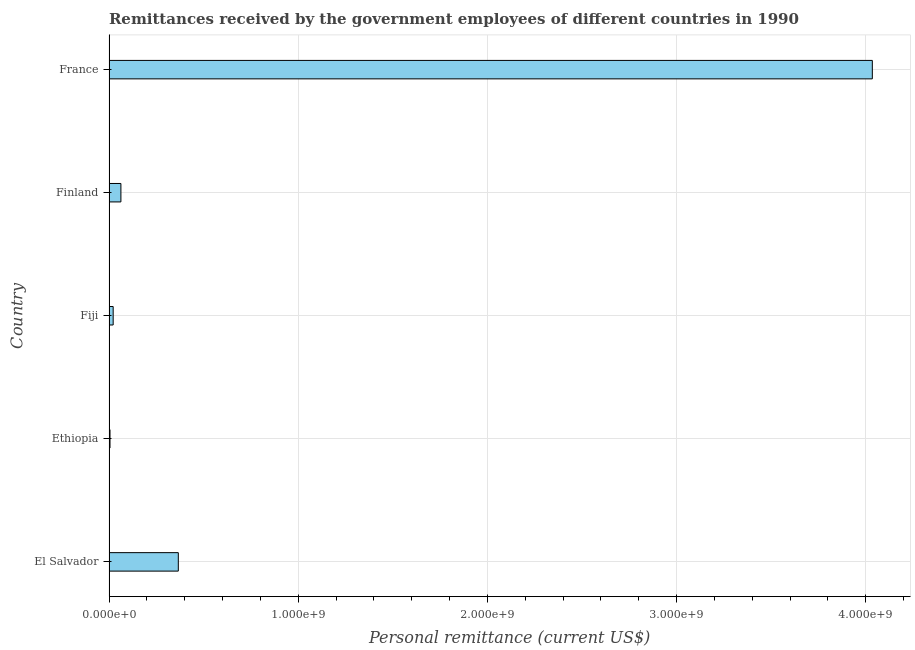What is the title of the graph?
Make the answer very short. Remittances received by the government employees of different countries in 1990. What is the label or title of the X-axis?
Your answer should be compact. Personal remittance (current US$). What is the personal remittances in France?
Your answer should be compact. 4.03e+09. Across all countries, what is the maximum personal remittances?
Your answer should be compact. 4.03e+09. Across all countries, what is the minimum personal remittances?
Offer a terse response. 5.22e+06. In which country was the personal remittances maximum?
Provide a short and direct response. France. In which country was the personal remittances minimum?
Offer a very short reply. Ethiopia. What is the sum of the personal remittances?
Your answer should be very brief. 4.49e+09. What is the difference between the personal remittances in El Salvador and Ethiopia?
Ensure brevity in your answer.  3.61e+08. What is the average personal remittances per country?
Give a very brief answer. 8.98e+08. What is the median personal remittances?
Make the answer very short. 6.29e+07. Is the personal remittances in Ethiopia less than that in Fiji?
Keep it short and to the point. Yes. Is the difference between the personal remittances in Fiji and France greater than the difference between any two countries?
Your answer should be compact. No. What is the difference between the highest and the second highest personal remittances?
Make the answer very short. 3.67e+09. Is the sum of the personal remittances in Finland and France greater than the maximum personal remittances across all countries?
Offer a very short reply. Yes. What is the difference between the highest and the lowest personal remittances?
Provide a succinct answer. 4.03e+09. In how many countries, is the personal remittances greater than the average personal remittances taken over all countries?
Make the answer very short. 1. How many bars are there?
Keep it short and to the point. 5. Are all the bars in the graph horizontal?
Keep it short and to the point. Yes. How many countries are there in the graph?
Your answer should be compact. 5. What is the Personal remittance (current US$) of El Salvador?
Offer a terse response. 3.66e+08. What is the Personal remittance (current US$) in Ethiopia?
Make the answer very short. 5.22e+06. What is the Personal remittance (current US$) in Fiji?
Ensure brevity in your answer.  2.19e+07. What is the Personal remittance (current US$) of Finland?
Provide a succinct answer. 6.29e+07. What is the Personal remittance (current US$) in France?
Provide a short and direct response. 4.03e+09. What is the difference between the Personal remittance (current US$) in El Salvador and Ethiopia?
Give a very brief answer. 3.61e+08. What is the difference between the Personal remittance (current US$) in El Salvador and Fiji?
Offer a very short reply. 3.44e+08. What is the difference between the Personal remittance (current US$) in El Salvador and Finland?
Offer a terse response. 3.03e+08. What is the difference between the Personal remittance (current US$) in El Salvador and France?
Offer a very short reply. -3.67e+09. What is the difference between the Personal remittance (current US$) in Ethiopia and Fiji?
Give a very brief answer. -1.67e+07. What is the difference between the Personal remittance (current US$) in Ethiopia and Finland?
Your answer should be very brief. -5.77e+07. What is the difference between the Personal remittance (current US$) in Ethiopia and France?
Your response must be concise. -4.03e+09. What is the difference between the Personal remittance (current US$) in Fiji and Finland?
Make the answer very short. -4.09e+07. What is the difference between the Personal remittance (current US$) in Fiji and France?
Your answer should be compact. -4.01e+09. What is the difference between the Personal remittance (current US$) in Finland and France?
Keep it short and to the point. -3.97e+09. What is the ratio of the Personal remittance (current US$) in El Salvador to that in Ethiopia?
Provide a short and direct response. 70.2. What is the ratio of the Personal remittance (current US$) in El Salvador to that in Fiji?
Offer a terse response. 16.69. What is the ratio of the Personal remittance (current US$) in El Salvador to that in Finland?
Ensure brevity in your answer.  5.83. What is the ratio of the Personal remittance (current US$) in El Salvador to that in France?
Provide a short and direct response. 0.09. What is the ratio of the Personal remittance (current US$) in Ethiopia to that in Fiji?
Your answer should be very brief. 0.24. What is the ratio of the Personal remittance (current US$) in Ethiopia to that in Finland?
Provide a short and direct response. 0.08. What is the ratio of the Personal remittance (current US$) in Ethiopia to that in France?
Provide a succinct answer. 0. What is the ratio of the Personal remittance (current US$) in Fiji to that in Finland?
Make the answer very short. 0.35. What is the ratio of the Personal remittance (current US$) in Fiji to that in France?
Offer a terse response. 0.01. What is the ratio of the Personal remittance (current US$) in Finland to that in France?
Offer a terse response. 0.02. 